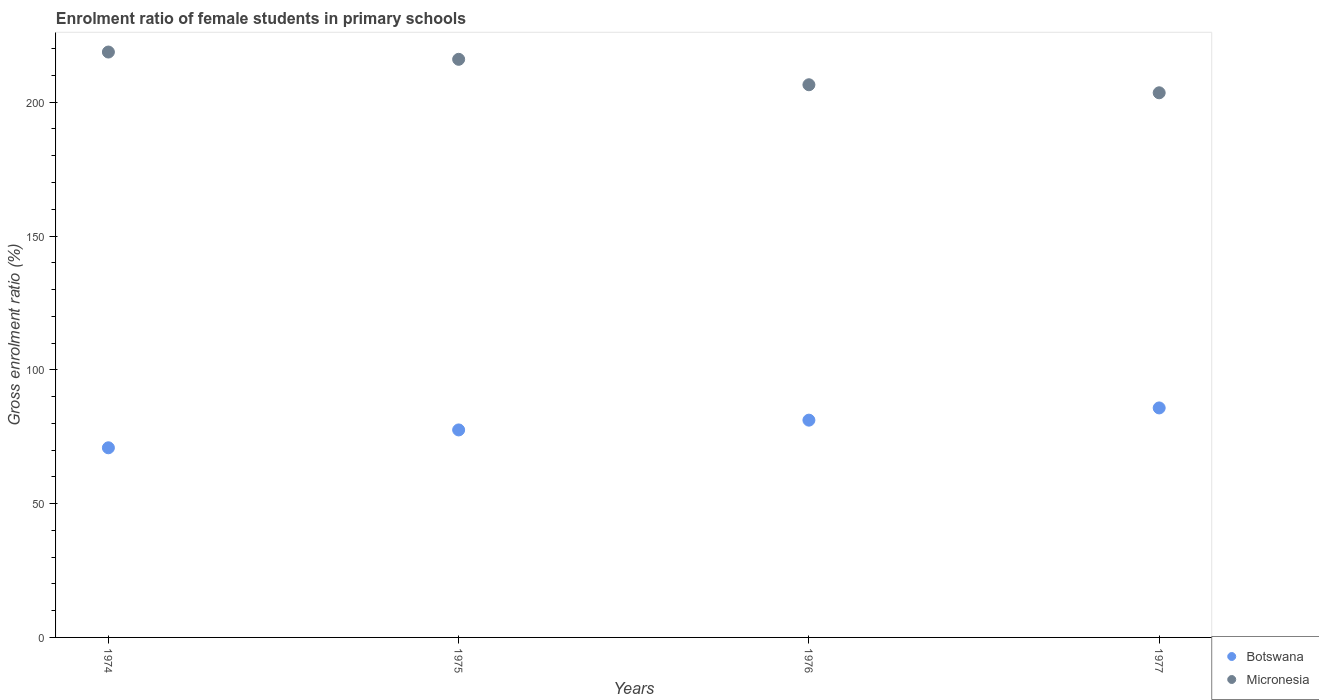How many different coloured dotlines are there?
Ensure brevity in your answer.  2. What is the enrolment ratio of female students in primary schools in Micronesia in 1975?
Offer a very short reply. 216.03. Across all years, what is the maximum enrolment ratio of female students in primary schools in Micronesia?
Ensure brevity in your answer.  218.75. Across all years, what is the minimum enrolment ratio of female students in primary schools in Botswana?
Offer a very short reply. 70.87. In which year was the enrolment ratio of female students in primary schools in Micronesia maximum?
Provide a short and direct response. 1974. In which year was the enrolment ratio of female students in primary schools in Micronesia minimum?
Make the answer very short. 1977. What is the total enrolment ratio of female students in primary schools in Botswana in the graph?
Offer a very short reply. 315.36. What is the difference between the enrolment ratio of female students in primary schools in Botswana in 1974 and that in 1975?
Provide a short and direct response. -6.67. What is the difference between the enrolment ratio of female students in primary schools in Micronesia in 1975 and the enrolment ratio of female students in primary schools in Botswana in 1974?
Your answer should be compact. 145.17. What is the average enrolment ratio of female students in primary schools in Botswana per year?
Provide a short and direct response. 78.84. In the year 1974, what is the difference between the enrolment ratio of female students in primary schools in Micronesia and enrolment ratio of female students in primary schools in Botswana?
Your answer should be very brief. 147.89. What is the ratio of the enrolment ratio of female students in primary schools in Micronesia in 1974 to that in 1975?
Offer a terse response. 1.01. Is the difference between the enrolment ratio of female students in primary schools in Micronesia in 1975 and 1976 greater than the difference between the enrolment ratio of female students in primary schools in Botswana in 1975 and 1976?
Your response must be concise. Yes. What is the difference between the highest and the second highest enrolment ratio of female students in primary schools in Micronesia?
Offer a very short reply. 2.72. What is the difference between the highest and the lowest enrolment ratio of female students in primary schools in Micronesia?
Make the answer very short. 15.23. In how many years, is the enrolment ratio of female students in primary schools in Micronesia greater than the average enrolment ratio of female students in primary schools in Micronesia taken over all years?
Make the answer very short. 2. Is the sum of the enrolment ratio of female students in primary schools in Micronesia in 1974 and 1975 greater than the maximum enrolment ratio of female students in primary schools in Botswana across all years?
Your response must be concise. Yes. How many dotlines are there?
Provide a short and direct response. 2. What is the difference between two consecutive major ticks on the Y-axis?
Offer a terse response. 50. Does the graph contain any zero values?
Offer a terse response. No. How are the legend labels stacked?
Make the answer very short. Vertical. What is the title of the graph?
Ensure brevity in your answer.  Enrolment ratio of female students in primary schools. Does "Portugal" appear as one of the legend labels in the graph?
Provide a short and direct response. No. What is the label or title of the X-axis?
Offer a very short reply. Years. What is the label or title of the Y-axis?
Give a very brief answer. Gross enrolment ratio (%). What is the Gross enrolment ratio (%) of Botswana in 1974?
Provide a succinct answer. 70.87. What is the Gross enrolment ratio (%) in Micronesia in 1974?
Provide a short and direct response. 218.75. What is the Gross enrolment ratio (%) of Botswana in 1975?
Your answer should be very brief. 77.54. What is the Gross enrolment ratio (%) of Micronesia in 1975?
Your response must be concise. 216.03. What is the Gross enrolment ratio (%) of Botswana in 1976?
Offer a very short reply. 81.19. What is the Gross enrolment ratio (%) of Micronesia in 1976?
Make the answer very short. 206.53. What is the Gross enrolment ratio (%) in Botswana in 1977?
Offer a terse response. 85.76. What is the Gross enrolment ratio (%) of Micronesia in 1977?
Give a very brief answer. 203.52. Across all years, what is the maximum Gross enrolment ratio (%) in Botswana?
Provide a short and direct response. 85.76. Across all years, what is the maximum Gross enrolment ratio (%) of Micronesia?
Ensure brevity in your answer.  218.75. Across all years, what is the minimum Gross enrolment ratio (%) in Botswana?
Make the answer very short. 70.87. Across all years, what is the minimum Gross enrolment ratio (%) in Micronesia?
Give a very brief answer. 203.52. What is the total Gross enrolment ratio (%) in Botswana in the graph?
Keep it short and to the point. 315.36. What is the total Gross enrolment ratio (%) in Micronesia in the graph?
Your answer should be very brief. 844.83. What is the difference between the Gross enrolment ratio (%) of Botswana in 1974 and that in 1975?
Offer a very short reply. -6.67. What is the difference between the Gross enrolment ratio (%) in Micronesia in 1974 and that in 1975?
Provide a short and direct response. 2.72. What is the difference between the Gross enrolment ratio (%) of Botswana in 1974 and that in 1976?
Your response must be concise. -10.33. What is the difference between the Gross enrolment ratio (%) of Micronesia in 1974 and that in 1976?
Give a very brief answer. 12.22. What is the difference between the Gross enrolment ratio (%) in Botswana in 1974 and that in 1977?
Your answer should be compact. -14.9. What is the difference between the Gross enrolment ratio (%) of Micronesia in 1974 and that in 1977?
Your answer should be very brief. 15.23. What is the difference between the Gross enrolment ratio (%) in Botswana in 1975 and that in 1976?
Provide a succinct answer. -3.65. What is the difference between the Gross enrolment ratio (%) in Micronesia in 1975 and that in 1976?
Make the answer very short. 9.5. What is the difference between the Gross enrolment ratio (%) in Botswana in 1975 and that in 1977?
Ensure brevity in your answer.  -8.22. What is the difference between the Gross enrolment ratio (%) in Micronesia in 1975 and that in 1977?
Make the answer very short. 12.51. What is the difference between the Gross enrolment ratio (%) of Botswana in 1976 and that in 1977?
Keep it short and to the point. -4.57. What is the difference between the Gross enrolment ratio (%) of Micronesia in 1976 and that in 1977?
Your answer should be very brief. 3.01. What is the difference between the Gross enrolment ratio (%) in Botswana in 1974 and the Gross enrolment ratio (%) in Micronesia in 1975?
Offer a very short reply. -145.17. What is the difference between the Gross enrolment ratio (%) of Botswana in 1974 and the Gross enrolment ratio (%) of Micronesia in 1976?
Your answer should be compact. -135.66. What is the difference between the Gross enrolment ratio (%) of Botswana in 1974 and the Gross enrolment ratio (%) of Micronesia in 1977?
Give a very brief answer. -132.66. What is the difference between the Gross enrolment ratio (%) in Botswana in 1975 and the Gross enrolment ratio (%) in Micronesia in 1976?
Offer a very short reply. -128.99. What is the difference between the Gross enrolment ratio (%) in Botswana in 1975 and the Gross enrolment ratio (%) in Micronesia in 1977?
Provide a short and direct response. -125.98. What is the difference between the Gross enrolment ratio (%) of Botswana in 1976 and the Gross enrolment ratio (%) of Micronesia in 1977?
Give a very brief answer. -122.33. What is the average Gross enrolment ratio (%) in Botswana per year?
Your answer should be compact. 78.84. What is the average Gross enrolment ratio (%) in Micronesia per year?
Provide a succinct answer. 211.21. In the year 1974, what is the difference between the Gross enrolment ratio (%) of Botswana and Gross enrolment ratio (%) of Micronesia?
Offer a terse response. -147.89. In the year 1975, what is the difference between the Gross enrolment ratio (%) of Botswana and Gross enrolment ratio (%) of Micronesia?
Provide a succinct answer. -138.49. In the year 1976, what is the difference between the Gross enrolment ratio (%) in Botswana and Gross enrolment ratio (%) in Micronesia?
Provide a short and direct response. -125.33. In the year 1977, what is the difference between the Gross enrolment ratio (%) in Botswana and Gross enrolment ratio (%) in Micronesia?
Offer a very short reply. -117.76. What is the ratio of the Gross enrolment ratio (%) in Botswana in 1974 to that in 1975?
Keep it short and to the point. 0.91. What is the ratio of the Gross enrolment ratio (%) of Micronesia in 1974 to that in 1975?
Keep it short and to the point. 1.01. What is the ratio of the Gross enrolment ratio (%) in Botswana in 1974 to that in 1976?
Your response must be concise. 0.87. What is the ratio of the Gross enrolment ratio (%) of Micronesia in 1974 to that in 1976?
Your answer should be compact. 1.06. What is the ratio of the Gross enrolment ratio (%) in Botswana in 1974 to that in 1977?
Your answer should be very brief. 0.83. What is the ratio of the Gross enrolment ratio (%) in Micronesia in 1974 to that in 1977?
Offer a very short reply. 1.07. What is the ratio of the Gross enrolment ratio (%) of Botswana in 1975 to that in 1976?
Keep it short and to the point. 0.95. What is the ratio of the Gross enrolment ratio (%) of Micronesia in 1975 to that in 1976?
Your answer should be very brief. 1.05. What is the ratio of the Gross enrolment ratio (%) of Botswana in 1975 to that in 1977?
Ensure brevity in your answer.  0.9. What is the ratio of the Gross enrolment ratio (%) in Micronesia in 1975 to that in 1977?
Offer a terse response. 1.06. What is the ratio of the Gross enrolment ratio (%) in Botswana in 1976 to that in 1977?
Offer a very short reply. 0.95. What is the ratio of the Gross enrolment ratio (%) in Micronesia in 1976 to that in 1977?
Provide a short and direct response. 1.01. What is the difference between the highest and the second highest Gross enrolment ratio (%) in Botswana?
Offer a terse response. 4.57. What is the difference between the highest and the second highest Gross enrolment ratio (%) in Micronesia?
Your answer should be compact. 2.72. What is the difference between the highest and the lowest Gross enrolment ratio (%) of Botswana?
Ensure brevity in your answer.  14.9. What is the difference between the highest and the lowest Gross enrolment ratio (%) in Micronesia?
Offer a very short reply. 15.23. 